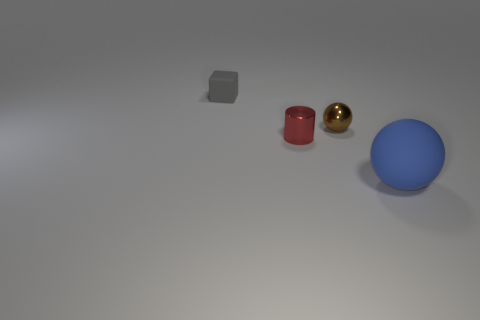Which object is the largest? The largest object in the image is the blue sphere on the right.  What could be the purpose of these objects? Without more context, it's challenging to determine their exact purpose, but they could represent generic 3D models used for visual effect tests, demonstrations in a physics simulation, or elements of a simple digital art composition. 